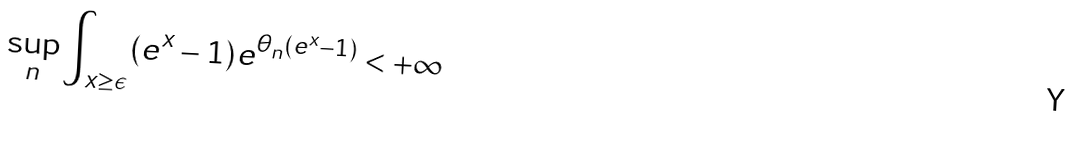<formula> <loc_0><loc_0><loc_500><loc_500>\sup _ { n } \int _ { x \geq \epsilon } ( e ^ { x } - 1 ) e ^ { \theta _ { n } ( e ^ { x } - 1 ) } < + \infty</formula> 